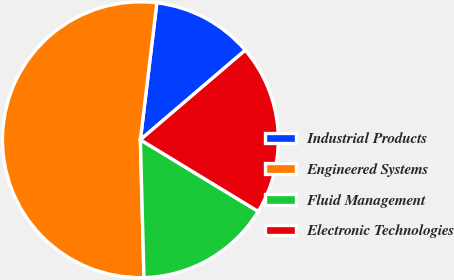Convert chart. <chart><loc_0><loc_0><loc_500><loc_500><pie_chart><fcel>Industrial Products<fcel>Engineered Systems<fcel>Fluid Management<fcel>Electronic Technologies<nl><fcel>11.85%<fcel>52.32%<fcel>15.89%<fcel>19.94%<nl></chart> 